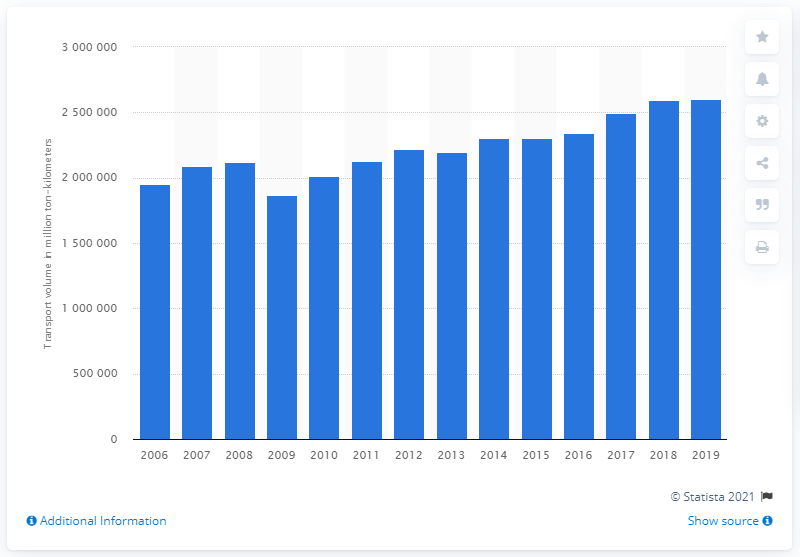Draw attention to some important aspects in this diagram. In 2019, Russia's rail freight volume was 260,249,300. 